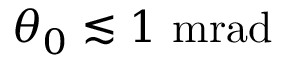<formula> <loc_0><loc_0><loc_500><loc_500>\theta _ { 0 } \lesssim 1 \ m r a d</formula> 